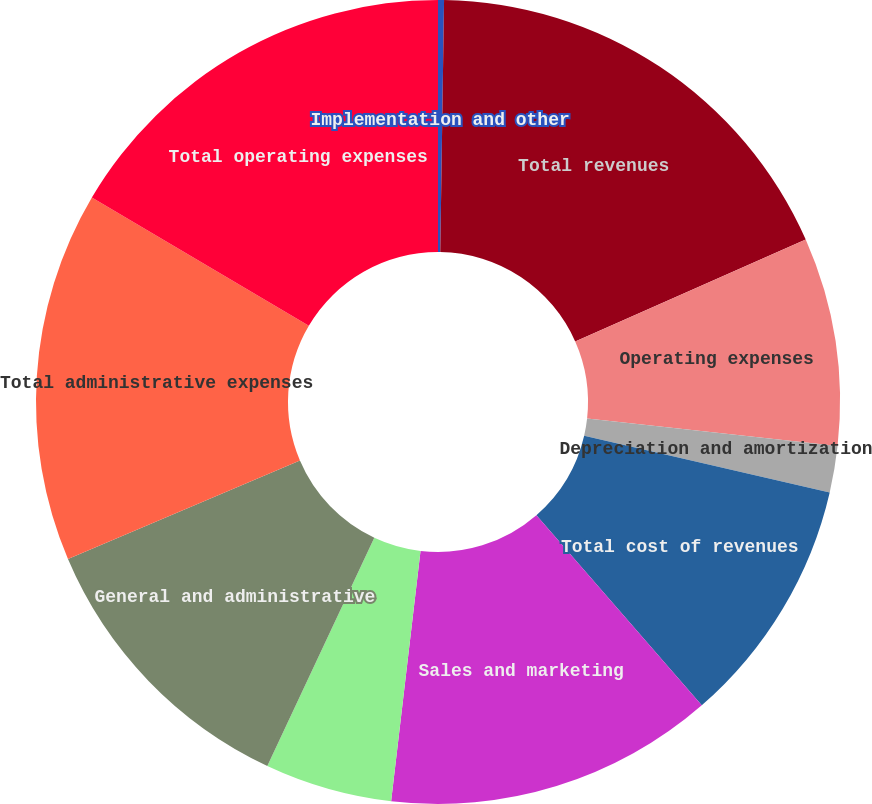<chart> <loc_0><loc_0><loc_500><loc_500><pie_chart><fcel>Implementation and other<fcel>Total revenues<fcel>Operating expenses<fcel>Depreciation and amortization<fcel>Total cost of revenues<fcel>Sales and marketing<fcel>Research and development<fcel>General and administrative<fcel>Total administrative expenses<fcel>Total operating expenses<nl><fcel>0.24%<fcel>18.14%<fcel>8.37%<fcel>1.86%<fcel>10.0%<fcel>13.25%<fcel>5.12%<fcel>11.63%<fcel>14.88%<fcel>16.51%<nl></chart> 